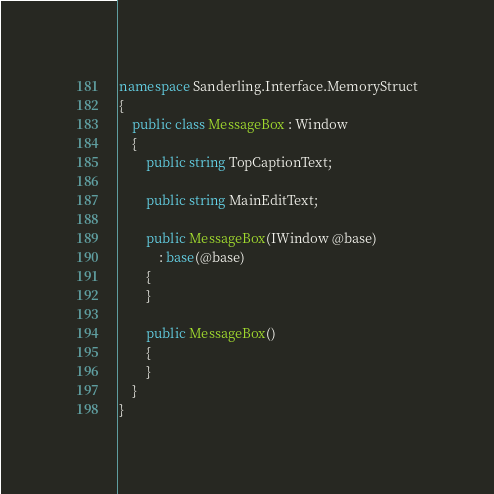<code> <loc_0><loc_0><loc_500><loc_500><_C#_>namespace Sanderling.Interface.MemoryStruct
{
	public class MessageBox : Window
	{
		public string TopCaptionText;

		public string MainEditText;

		public MessageBox(IWindow @base)
			: base(@base)
		{
		}

		public MessageBox()
		{
		}
	}
}
</code> 